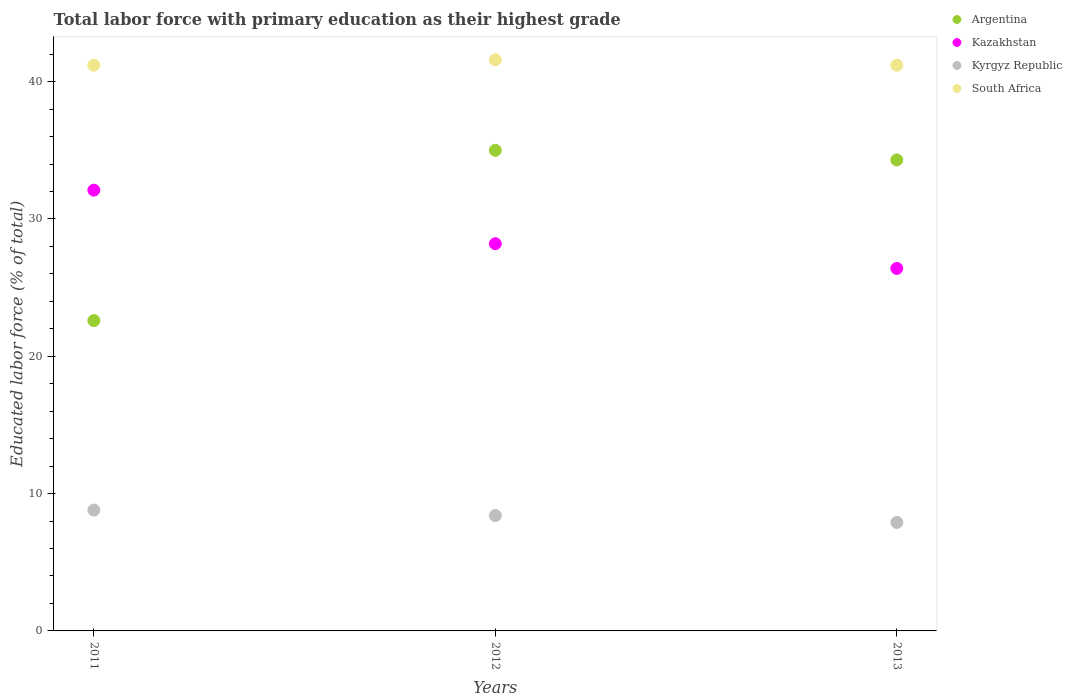What is the percentage of total labor force with primary education in Kazakhstan in 2013?
Offer a very short reply. 26.4. Across all years, what is the maximum percentage of total labor force with primary education in Argentina?
Make the answer very short. 35. Across all years, what is the minimum percentage of total labor force with primary education in South Africa?
Your answer should be compact. 41.2. What is the total percentage of total labor force with primary education in Kazakhstan in the graph?
Provide a short and direct response. 86.7. What is the difference between the percentage of total labor force with primary education in South Africa in 2012 and that in 2013?
Provide a succinct answer. 0.4. What is the difference between the percentage of total labor force with primary education in South Africa in 2011 and the percentage of total labor force with primary education in Kazakhstan in 2013?
Offer a very short reply. 14.8. What is the average percentage of total labor force with primary education in Kazakhstan per year?
Keep it short and to the point. 28.9. In the year 2013, what is the difference between the percentage of total labor force with primary education in Kyrgyz Republic and percentage of total labor force with primary education in Kazakhstan?
Your answer should be very brief. -18.5. In how many years, is the percentage of total labor force with primary education in South Africa greater than 38 %?
Provide a succinct answer. 3. What is the ratio of the percentage of total labor force with primary education in South Africa in 2011 to that in 2012?
Provide a succinct answer. 0.99. Is the percentage of total labor force with primary education in Kyrgyz Republic in 2012 less than that in 2013?
Ensure brevity in your answer.  No. What is the difference between the highest and the second highest percentage of total labor force with primary education in Kyrgyz Republic?
Ensure brevity in your answer.  0.4. What is the difference between the highest and the lowest percentage of total labor force with primary education in Kazakhstan?
Provide a succinct answer. 5.7. In how many years, is the percentage of total labor force with primary education in South Africa greater than the average percentage of total labor force with primary education in South Africa taken over all years?
Make the answer very short. 1. Is it the case that in every year, the sum of the percentage of total labor force with primary education in South Africa and percentage of total labor force with primary education in Kazakhstan  is greater than the percentage of total labor force with primary education in Kyrgyz Republic?
Offer a terse response. Yes. Is the percentage of total labor force with primary education in Kyrgyz Republic strictly greater than the percentage of total labor force with primary education in Argentina over the years?
Provide a short and direct response. No. Is the percentage of total labor force with primary education in South Africa strictly less than the percentage of total labor force with primary education in Kyrgyz Republic over the years?
Provide a succinct answer. No. How many dotlines are there?
Make the answer very short. 4. What is the difference between two consecutive major ticks on the Y-axis?
Your response must be concise. 10. Are the values on the major ticks of Y-axis written in scientific E-notation?
Make the answer very short. No. How are the legend labels stacked?
Make the answer very short. Vertical. What is the title of the graph?
Ensure brevity in your answer.  Total labor force with primary education as their highest grade. Does "Honduras" appear as one of the legend labels in the graph?
Give a very brief answer. No. What is the label or title of the X-axis?
Ensure brevity in your answer.  Years. What is the label or title of the Y-axis?
Keep it short and to the point. Educated labor force (% of total). What is the Educated labor force (% of total) of Argentina in 2011?
Provide a short and direct response. 22.6. What is the Educated labor force (% of total) in Kazakhstan in 2011?
Give a very brief answer. 32.1. What is the Educated labor force (% of total) of Kyrgyz Republic in 2011?
Offer a very short reply. 8.8. What is the Educated labor force (% of total) in South Africa in 2011?
Offer a terse response. 41.2. What is the Educated labor force (% of total) of Argentina in 2012?
Make the answer very short. 35. What is the Educated labor force (% of total) of Kazakhstan in 2012?
Make the answer very short. 28.2. What is the Educated labor force (% of total) in Kyrgyz Republic in 2012?
Provide a short and direct response. 8.4. What is the Educated labor force (% of total) of South Africa in 2012?
Provide a short and direct response. 41.6. What is the Educated labor force (% of total) in Argentina in 2013?
Your answer should be very brief. 34.3. What is the Educated labor force (% of total) of Kazakhstan in 2013?
Give a very brief answer. 26.4. What is the Educated labor force (% of total) of Kyrgyz Republic in 2013?
Your answer should be compact. 7.9. What is the Educated labor force (% of total) in South Africa in 2013?
Provide a succinct answer. 41.2. Across all years, what is the maximum Educated labor force (% of total) in Argentina?
Ensure brevity in your answer.  35. Across all years, what is the maximum Educated labor force (% of total) of Kazakhstan?
Ensure brevity in your answer.  32.1. Across all years, what is the maximum Educated labor force (% of total) in Kyrgyz Republic?
Give a very brief answer. 8.8. Across all years, what is the maximum Educated labor force (% of total) in South Africa?
Offer a terse response. 41.6. Across all years, what is the minimum Educated labor force (% of total) of Argentina?
Your response must be concise. 22.6. Across all years, what is the minimum Educated labor force (% of total) in Kazakhstan?
Provide a succinct answer. 26.4. Across all years, what is the minimum Educated labor force (% of total) of Kyrgyz Republic?
Offer a terse response. 7.9. Across all years, what is the minimum Educated labor force (% of total) of South Africa?
Offer a very short reply. 41.2. What is the total Educated labor force (% of total) in Argentina in the graph?
Provide a succinct answer. 91.9. What is the total Educated labor force (% of total) in Kazakhstan in the graph?
Offer a terse response. 86.7. What is the total Educated labor force (% of total) of Kyrgyz Republic in the graph?
Keep it short and to the point. 25.1. What is the total Educated labor force (% of total) in South Africa in the graph?
Offer a terse response. 124. What is the difference between the Educated labor force (% of total) of Argentina in 2011 and that in 2012?
Provide a short and direct response. -12.4. What is the difference between the Educated labor force (% of total) in Kyrgyz Republic in 2011 and that in 2012?
Provide a succinct answer. 0.4. What is the difference between the Educated labor force (% of total) in South Africa in 2011 and that in 2012?
Give a very brief answer. -0.4. What is the difference between the Educated labor force (% of total) in Kazakhstan in 2011 and that in 2013?
Provide a succinct answer. 5.7. What is the difference between the Educated labor force (% of total) in Kazakhstan in 2012 and that in 2013?
Make the answer very short. 1.8. What is the difference between the Educated labor force (% of total) in Kyrgyz Republic in 2012 and that in 2013?
Provide a short and direct response. 0.5. What is the difference between the Educated labor force (% of total) of Argentina in 2011 and the Educated labor force (% of total) of Kyrgyz Republic in 2012?
Give a very brief answer. 14.2. What is the difference between the Educated labor force (% of total) in Kazakhstan in 2011 and the Educated labor force (% of total) in Kyrgyz Republic in 2012?
Make the answer very short. 23.7. What is the difference between the Educated labor force (% of total) in Kyrgyz Republic in 2011 and the Educated labor force (% of total) in South Africa in 2012?
Ensure brevity in your answer.  -32.8. What is the difference between the Educated labor force (% of total) of Argentina in 2011 and the Educated labor force (% of total) of South Africa in 2013?
Offer a very short reply. -18.6. What is the difference between the Educated labor force (% of total) of Kazakhstan in 2011 and the Educated labor force (% of total) of Kyrgyz Republic in 2013?
Your response must be concise. 24.2. What is the difference between the Educated labor force (% of total) of Kyrgyz Republic in 2011 and the Educated labor force (% of total) of South Africa in 2013?
Give a very brief answer. -32.4. What is the difference between the Educated labor force (% of total) of Argentina in 2012 and the Educated labor force (% of total) of Kazakhstan in 2013?
Provide a short and direct response. 8.6. What is the difference between the Educated labor force (% of total) in Argentina in 2012 and the Educated labor force (% of total) in Kyrgyz Republic in 2013?
Keep it short and to the point. 27.1. What is the difference between the Educated labor force (% of total) in Kazakhstan in 2012 and the Educated labor force (% of total) in Kyrgyz Republic in 2013?
Your response must be concise. 20.3. What is the difference between the Educated labor force (% of total) in Kyrgyz Republic in 2012 and the Educated labor force (% of total) in South Africa in 2013?
Keep it short and to the point. -32.8. What is the average Educated labor force (% of total) of Argentina per year?
Provide a short and direct response. 30.63. What is the average Educated labor force (% of total) in Kazakhstan per year?
Offer a terse response. 28.9. What is the average Educated labor force (% of total) of Kyrgyz Republic per year?
Provide a succinct answer. 8.37. What is the average Educated labor force (% of total) in South Africa per year?
Offer a terse response. 41.33. In the year 2011, what is the difference between the Educated labor force (% of total) in Argentina and Educated labor force (% of total) in Kazakhstan?
Make the answer very short. -9.5. In the year 2011, what is the difference between the Educated labor force (% of total) of Argentina and Educated labor force (% of total) of Kyrgyz Republic?
Your answer should be very brief. 13.8. In the year 2011, what is the difference between the Educated labor force (% of total) in Argentina and Educated labor force (% of total) in South Africa?
Keep it short and to the point. -18.6. In the year 2011, what is the difference between the Educated labor force (% of total) of Kazakhstan and Educated labor force (% of total) of Kyrgyz Republic?
Offer a very short reply. 23.3. In the year 2011, what is the difference between the Educated labor force (% of total) in Kyrgyz Republic and Educated labor force (% of total) in South Africa?
Offer a terse response. -32.4. In the year 2012, what is the difference between the Educated labor force (% of total) of Argentina and Educated labor force (% of total) of Kyrgyz Republic?
Make the answer very short. 26.6. In the year 2012, what is the difference between the Educated labor force (% of total) in Argentina and Educated labor force (% of total) in South Africa?
Provide a succinct answer. -6.6. In the year 2012, what is the difference between the Educated labor force (% of total) of Kazakhstan and Educated labor force (% of total) of Kyrgyz Republic?
Provide a short and direct response. 19.8. In the year 2012, what is the difference between the Educated labor force (% of total) of Kyrgyz Republic and Educated labor force (% of total) of South Africa?
Provide a short and direct response. -33.2. In the year 2013, what is the difference between the Educated labor force (% of total) in Argentina and Educated labor force (% of total) in Kazakhstan?
Ensure brevity in your answer.  7.9. In the year 2013, what is the difference between the Educated labor force (% of total) in Argentina and Educated labor force (% of total) in Kyrgyz Republic?
Ensure brevity in your answer.  26.4. In the year 2013, what is the difference between the Educated labor force (% of total) in Argentina and Educated labor force (% of total) in South Africa?
Make the answer very short. -6.9. In the year 2013, what is the difference between the Educated labor force (% of total) of Kazakhstan and Educated labor force (% of total) of South Africa?
Your response must be concise. -14.8. In the year 2013, what is the difference between the Educated labor force (% of total) in Kyrgyz Republic and Educated labor force (% of total) in South Africa?
Keep it short and to the point. -33.3. What is the ratio of the Educated labor force (% of total) of Argentina in 2011 to that in 2012?
Ensure brevity in your answer.  0.65. What is the ratio of the Educated labor force (% of total) of Kazakhstan in 2011 to that in 2012?
Provide a succinct answer. 1.14. What is the ratio of the Educated labor force (% of total) of Kyrgyz Republic in 2011 to that in 2012?
Provide a short and direct response. 1.05. What is the ratio of the Educated labor force (% of total) of South Africa in 2011 to that in 2012?
Your answer should be very brief. 0.99. What is the ratio of the Educated labor force (% of total) of Argentina in 2011 to that in 2013?
Give a very brief answer. 0.66. What is the ratio of the Educated labor force (% of total) of Kazakhstan in 2011 to that in 2013?
Your answer should be compact. 1.22. What is the ratio of the Educated labor force (% of total) of Kyrgyz Republic in 2011 to that in 2013?
Ensure brevity in your answer.  1.11. What is the ratio of the Educated labor force (% of total) of South Africa in 2011 to that in 2013?
Your answer should be very brief. 1. What is the ratio of the Educated labor force (% of total) in Argentina in 2012 to that in 2013?
Make the answer very short. 1.02. What is the ratio of the Educated labor force (% of total) in Kazakhstan in 2012 to that in 2013?
Keep it short and to the point. 1.07. What is the ratio of the Educated labor force (% of total) of Kyrgyz Republic in 2012 to that in 2013?
Provide a short and direct response. 1.06. What is the ratio of the Educated labor force (% of total) in South Africa in 2012 to that in 2013?
Your response must be concise. 1.01. What is the difference between the highest and the second highest Educated labor force (% of total) in Kazakhstan?
Keep it short and to the point. 3.9. What is the difference between the highest and the second highest Educated labor force (% of total) of South Africa?
Your answer should be compact. 0.4. What is the difference between the highest and the lowest Educated labor force (% of total) in Argentina?
Offer a very short reply. 12.4. What is the difference between the highest and the lowest Educated labor force (% of total) in Kazakhstan?
Your answer should be compact. 5.7. What is the difference between the highest and the lowest Educated labor force (% of total) in South Africa?
Make the answer very short. 0.4. 